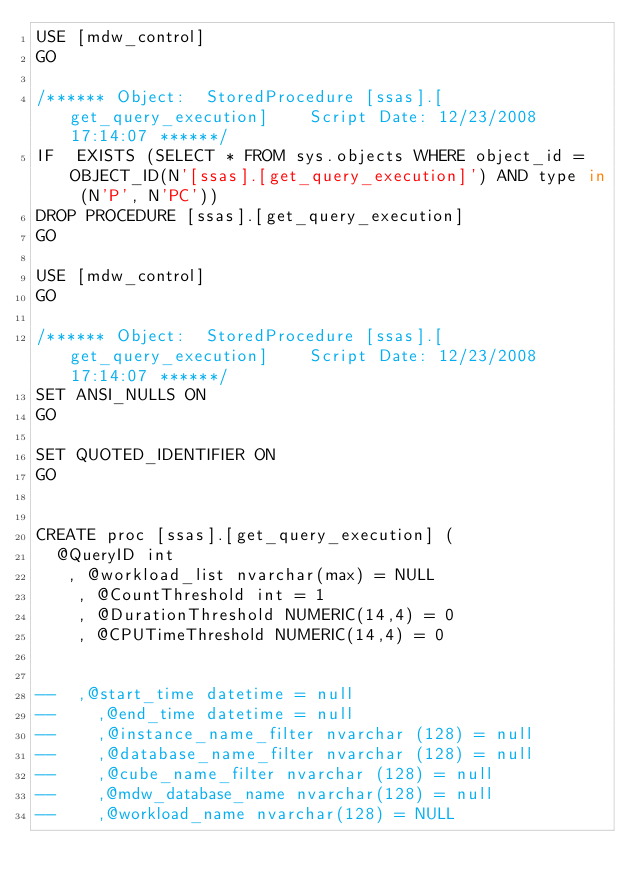Convert code to text. <code><loc_0><loc_0><loc_500><loc_500><_SQL_>USE [mdw_control]
GO

/****** Object:  StoredProcedure [ssas].[get_query_execution]    Script Date: 12/23/2008 17:14:07 ******/
IF  EXISTS (SELECT * FROM sys.objects WHERE object_id = OBJECT_ID(N'[ssas].[get_query_execution]') AND type in (N'P', N'PC'))
DROP PROCEDURE [ssas].[get_query_execution]
GO

USE [mdw_control]
GO

/****** Object:  StoredProcedure [ssas].[get_query_execution]    Script Date: 12/23/2008 17:14:07 ******/
SET ANSI_NULLS ON
GO

SET QUOTED_IDENTIFIER ON
GO


CREATE proc [ssas].[get_query_execution] (
	@QueryID int
   , @workload_list nvarchar(max) = NULL
    , @CountThreshold int = 1
    , @DurationThreshold NUMERIC(14,4) = 0
    , @CPUTimeThreshold NUMERIC(14,4) = 0


--	,@start_time datetime = null
--    ,@end_time datetime = null  
--    ,@instance_name_filter nvarchar (128) = null
--    ,@database_name_filter nvarchar (128) = null
--    ,@cube_name_filter nvarchar (128) = null
--    ,@mdw_database_name nvarchar(128) = null
--    ,@workload_name nvarchar(128) = NULL</code> 